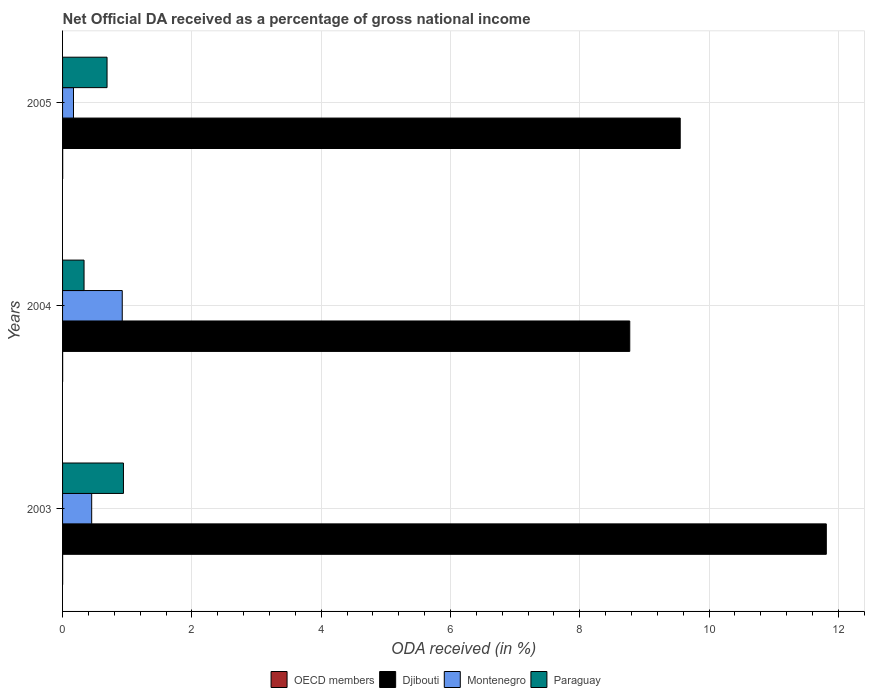How many bars are there on the 2nd tick from the top?
Your answer should be compact. 4. What is the net official DA received in Djibouti in 2003?
Offer a terse response. 11.81. Across all years, what is the maximum net official DA received in OECD members?
Provide a succinct answer. 0. Across all years, what is the minimum net official DA received in Paraguay?
Your answer should be compact. 0.33. What is the total net official DA received in OECD members in the graph?
Keep it short and to the point. 0. What is the difference between the net official DA received in Djibouti in 2003 and that in 2005?
Your response must be concise. 2.26. What is the difference between the net official DA received in OECD members in 2004 and the net official DA received in Paraguay in 2003?
Offer a terse response. -0.94. What is the average net official DA received in Montenegro per year?
Keep it short and to the point. 0.51. In the year 2003, what is the difference between the net official DA received in Djibouti and net official DA received in Montenegro?
Offer a very short reply. 11.36. What is the ratio of the net official DA received in Djibouti in 2003 to that in 2004?
Make the answer very short. 1.35. What is the difference between the highest and the second highest net official DA received in Paraguay?
Provide a succinct answer. 0.25. What is the difference between the highest and the lowest net official DA received in Montenegro?
Your answer should be very brief. 0.75. What does the 3rd bar from the top in 2005 represents?
Your answer should be compact. Djibouti. What does the 4th bar from the bottom in 2004 represents?
Offer a terse response. Paraguay. Are the values on the major ticks of X-axis written in scientific E-notation?
Offer a terse response. No. Does the graph contain grids?
Your answer should be compact. Yes. What is the title of the graph?
Provide a short and direct response. Net Official DA received as a percentage of gross national income. What is the label or title of the X-axis?
Your answer should be compact. ODA received (in %). What is the label or title of the Y-axis?
Your response must be concise. Years. What is the ODA received (in %) in OECD members in 2003?
Your answer should be compact. 0. What is the ODA received (in %) of Djibouti in 2003?
Offer a terse response. 11.81. What is the ODA received (in %) in Montenegro in 2003?
Give a very brief answer. 0.45. What is the ODA received (in %) of Paraguay in 2003?
Provide a short and direct response. 0.94. What is the ODA received (in %) of OECD members in 2004?
Keep it short and to the point. 0. What is the ODA received (in %) in Djibouti in 2004?
Offer a terse response. 8.77. What is the ODA received (in %) in Montenegro in 2004?
Your answer should be very brief. 0.92. What is the ODA received (in %) of Paraguay in 2004?
Your answer should be compact. 0.33. What is the ODA received (in %) of OECD members in 2005?
Offer a terse response. 0. What is the ODA received (in %) in Djibouti in 2005?
Your response must be concise. 9.55. What is the ODA received (in %) of Montenegro in 2005?
Your answer should be compact. 0.17. What is the ODA received (in %) of Paraguay in 2005?
Ensure brevity in your answer.  0.69. Across all years, what is the maximum ODA received (in %) in OECD members?
Make the answer very short. 0. Across all years, what is the maximum ODA received (in %) of Djibouti?
Keep it short and to the point. 11.81. Across all years, what is the maximum ODA received (in %) of Montenegro?
Provide a short and direct response. 0.92. Across all years, what is the maximum ODA received (in %) of Paraguay?
Ensure brevity in your answer.  0.94. Across all years, what is the minimum ODA received (in %) in OECD members?
Ensure brevity in your answer.  0. Across all years, what is the minimum ODA received (in %) in Djibouti?
Provide a succinct answer. 8.77. Across all years, what is the minimum ODA received (in %) in Montenegro?
Your response must be concise. 0.17. Across all years, what is the minimum ODA received (in %) in Paraguay?
Provide a succinct answer. 0.33. What is the total ODA received (in %) in OECD members in the graph?
Give a very brief answer. 0. What is the total ODA received (in %) in Djibouti in the graph?
Your response must be concise. 30.14. What is the total ODA received (in %) of Montenegro in the graph?
Your answer should be very brief. 1.54. What is the total ODA received (in %) in Paraguay in the graph?
Your response must be concise. 1.96. What is the difference between the ODA received (in %) in OECD members in 2003 and that in 2004?
Ensure brevity in your answer.  -0. What is the difference between the ODA received (in %) in Djibouti in 2003 and that in 2004?
Provide a succinct answer. 3.04. What is the difference between the ODA received (in %) of Montenegro in 2003 and that in 2004?
Give a very brief answer. -0.47. What is the difference between the ODA received (in %) of Paraguay in 2003 and that in 2004?
Provide a short and direct response. 0.61. What is the difference between the ODA received (in %) of OECD members in 2003 and that in 2005?
Offer a terse response. -0. What is the difference between the ODA received (in %) in Djibouti in 2003 and that in 2005?
Provide a short and direct response. 2.26. What is the difference between the ODA received (in %) in Montenegro in 2003 and that in 2005?
Your answer should be compact. 0.28. What is the difference between the ODA received (in %) in Paraguay in 2003 and that in 2005?
Ensure brevity in your answer.  0.25. What is the difference between the ODA received (in %) of OECD members in 2004 and that in 2005?
Keep it short and to the point. -0. What is the difference between the ODA received (in %) of Djibouti in 2004 and that in 2005?
Ensure brevity in your answer.  -0.78. What is the difference between the ODA received (in %) of Montenegro in 2004 and that in 2005?
Give a very brief answer. 0.75. What is the difference between the ODA received (in %) in Paraguay in 2004 and that in 2005?
Offer a terse response. -0.36. What is the difference between the ODA received (in %) of OECD members in 2003 and the ODA received (in %) of Djibouti in 2004?
Ensure brevity in your answer.  -8.77. What is the difference between the ODA received (in %) in OECD members in 2003 and the ODA received (in %) in Montenegro in 2004?
Your response must be concise. -0.92. What is the difference between the ODA received (in %) of OECD members in 2003 and the ODA received (in %) of Paraguay in 2004?
Ensure brevity in your answer.  -0.33. What is the difference between the ODA received (in %) of Djibouti in 2003 and the ODA received (in %) of Montenegro in 2004?
Provide a short and direct response. 10.89. What is the difference between the ODA received (in %) in Djibouti in 2003 and the ODA received (in %) in Paraguay in 2004?
Offer a very short reply. 11.48. What is the difference between the ODA received (in %) in Montenegro in 2003 and the ODA received (in %) in Paraguay in 2004?
Give a very brief answer. 0.12. What is the difference between the ODA received (in %) of OECD members in 2003 and the ODA received (in %) of Djibouti in 2005?
Your response must be concise. -9.55. What is the difference between the ODA received (in %) in OECD members in 2003 and the ODA received (in %) in Montenegro in 2005?
Your response must be concise. -0.17. What is the difference between the ODA received (in %) of OECD members in 2003 and the ODA received (in %) of Paraguay in 2005?
Your response must be concise. -0.69. What is the difference between the ODA received (in %) of Djibouti in 2003 and the ODA received (in %) of Montenegro in 2005?
Your response must be concise. 11.64. What is the difference between the ODA received (in %) in Djibouti in 2003 and the ODA received (in %) in Paraguay in 2005?
Give a very brief answer. 11.13. What is the difference between the ODA received (in %) in Montenegro in 2003 and the ODA received (in %) in Paraguay in 2005?
Your answer should be very brief. -0.24. What is the difference between the ODA received (in %) of OECD members in 2004 and the ODA received (in %) of Djibouti in 2005?
Your response must be concise. -9.55. What is the difference between the ODA received (in %) of OECD members in 2004 and the ODA received (in %) of Montenegro in 2005?
Give a very brief answer. -0.17. What is the difference between the ODA received (in %) of OECD members in 2004 and the ODA received (in %) of Paraguay in 2005?
Your answer should be compact. -0.69. What is the difference between the ODA received (in %) in Djibouti in 2004 and the ODA received (in %) in Montenegro in 2005?
Keep it short and to the point. 8.6. What is the difference between the ODA received (in %) of Djibouti in 2004 and the ODA received (in %) of Paraguay in 2005?
Offer a very short reply. 8.09. What is the difference between the ODA received (in %) of Montenegro in 2004 and the ODA received (in %) of Paraguay in 2005?
Your answer should be very brief. 0.24. What is the average ODA received (in %) of OECD members per year?
Offer a very short reply. 0. What is the average ODA received (in %) in Djibouti per year?
Provide a short and direct response. 10.05. What is the average ODA received (in %) of Montenegro per year?
Offer a terse response. 0.51. What is the average ODA received (in %) of Paraguay per year?
Offer a terse response. 0.65. In the year 2003, what is the difference between the ODA received (in %) of OECD members and ODA received (in %) of Djibouti?
Offer a terse response. -11.81. In the year 2003, what is the difference between the ODA received (in %) of OECD members and ODA received (in %) of Montenegro?
Keep it short and to the point. -0.45. In the year 2003, what is the difference between the ODA received (in %) of OECD members and ODA received (in %) of Paraguay?
Provide a succinct answer. -0.94. In the year 2003, what is the difference between the ODA received (in %) of Djibouti and ODA received (in %) of Montenegro?
Keep it short and to the point. 11.36. In the year 2003, what is the difference between the ODA received (in %) in Djibouti and ODA received (in %) in Paraguay?
Give a very brief answer. 10.87. In the year 2003, what is the difference between the ODA received (in %) in Montenegro and ODA received (in %) in Paraguay?
Your answer should be compact. -0.49. In the year 2004, what is the difference between the ODA received (in %) in OECD members and ODA received (in %) in Djibouti?
Offer a terse response. -8.77. In the year 2004, what is the difference between the ODA received (in %) in OECD members and ODA received (in %) in Montenegro?
Keep it short and to the point. -0.92. In the year 2004, what is the difference between the ODA received (in %) in OECD members and ODA received (in %) in Paraguay?
Keep it short and to the point. -0.33. In the year 2004, what is the difference between the ODA received (in %) in Djibouti and ODA received (in %) in Montenegro?
Your response must be concise. 7.85. In the year 2004, what is the difference between the ODA received (in %) of Djibouti and ODA received (in %) of Paraguay?
Provide a short and direct response. 8.44. In the year 2004, what is the difference between the ODA received (in %) of Montenegro and ODA received (in %) of Paraguay?
Keep it short and to the point. 0.59. In the year 2005, what is the difference between the ODA received (in %) in OECD members and ODA received (in %) in Djibouti?
Offer a very short reply. -9.55. In the year 2005, what is the difference between the ODA received (in %) of OECD members and ODA received (in %) of Montenegro?
Provide a succinct answer. -0.17. In the year 2005, what is the difference between the ODA received (in %) of OECD members and ODA received (in %) of Paraguay?
Give a very brief answer. -0.69. In the year 2005, what is the difference between the ODA received (in %) in Djibouti and ODA received (in %) in Montenegro?
Keep it short and to the point. 9.38. In the year 2005, what is the difference between the ODA received (in %) in Djibouti and ODA received (in %) in Paraguay?
Provide a short and direct response. 8.87. In the year 2005, what is the difference between the ODA received (in %) of Montenegro and ODA received (in %) of Paraguay?
Your answer should be very brief. -0.52. What is the ratio of the ODA received (in %) of OECD members in 2003 to that in 2004?
Provide a succinct answer. 0.93. What is the ratio of the ODA received (in %) in Djibouti in 2003 to that in 2004?
Provide a succinct answer. 1.35. What is the ratio of the ODA received (in %) of Montenegro in 2003 to that in 2004?
Make the answer very short. 0.49. What is the ratio of the ODA received (in %) in Paraguay in 2003 to that in 2004?
Provide a succinct answer. 2.83. What is the ratio of the ODA received (in %) of OECD members in 2003 to that in 2005?
Your answer should be compact. 0.59. What is the ratio of the ODA received (in %) of Djibouti in 2003 to that in 2005?
Your answer should be compact. 1.24. What is the ratio of the ODA received (in %) in Montenegro in 2003 to that in 2005?
Keep it short and to the point. 2.66. What is the ratio of the ODA received (in %) of Paraguay in 2003 to that in 2005?
Provide a short and direct response. 1.37. What is the ratio of the ODA received (in %) of OECD members in 2004 to that in 2005?
Provide a succinct answer. 0.64. What is the ratio of the ODA received (in %) of Djibouti in 2004 to that in 2005?
Give a very brief answer. 0.92. What is the ratio of the ODA received (in %) in Montenegro in 2004 to that in 2005?
Your response must be concise. 5.46. What is the ratio of the ODA received (in %) of Paraguay in 2004 to that in 2005?
Ensure brevity in your answer.  0.48. What is the difference between the highest and the second highest ODA received (in %) in OECD members?
Give a very brief answer. 0. What is the difference between the highest and the second highest ODA received (in %) of Djibouti?
Provide a short and direct response. 2.26. What is the difference between the highest and the second highest ODA received (in %) in Montenegro?
Provide a succinct answer. 0.47. What is the difference between the highest and the second highest ODA received (in %) of Paraguay?
Offer a terse response. 0.25. What is the difference between the highest and the lowest ODA received (in %) of OECD members?
Provide a short and direct response. 0. What is the difference between the highest and the lowest ODA received (in %) of Djibouti?
Offer a very short reply. 3.04. What is the difference between the highest and the lowest ODA received (in %) of Montenegro?
Your answer should be compact. 0.75. What is the difference between the highest and the lowest ODA received (in %) in Paraguay?
Offer a terse response. 0.61. 